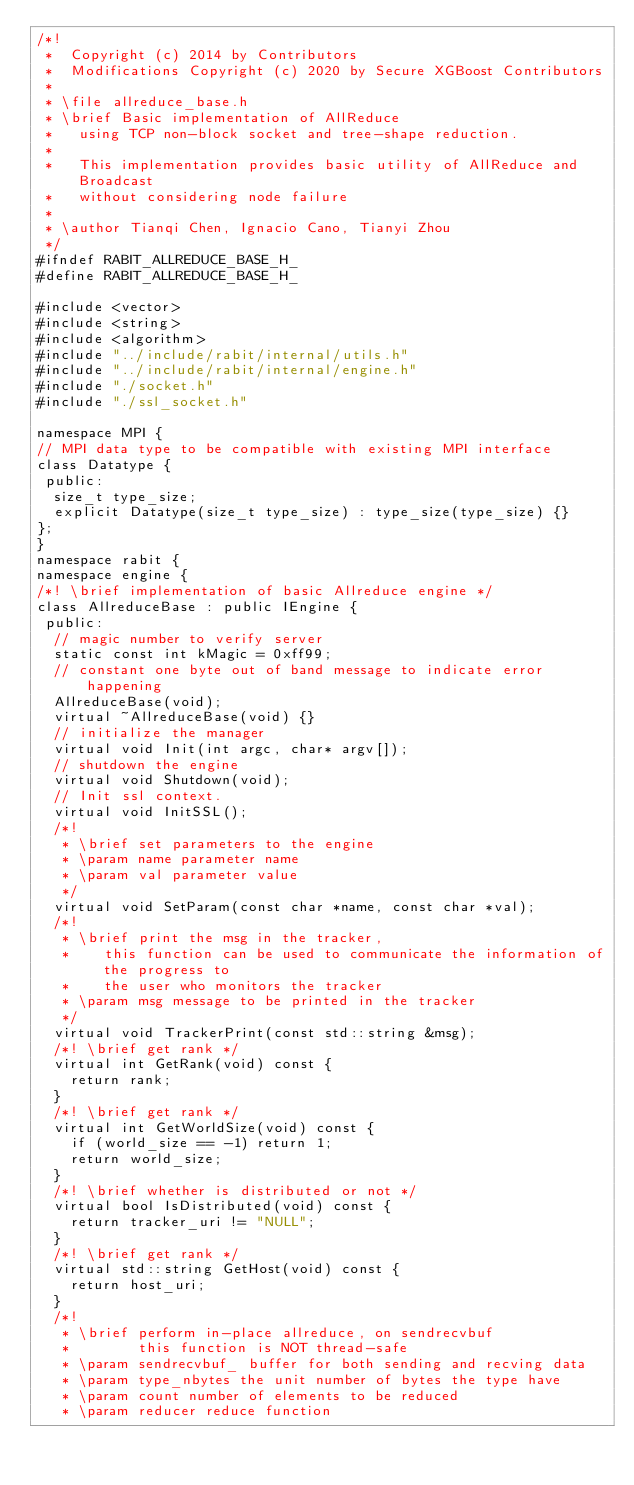Convert code to text. <code><loc_0><loc_0><loc_500><loc_500><_C_>/*!
 *  Copyright (c) 2014 by Contributors
 *  Modifications Copyright (c) 2020 by Secure XGBoost Contributors
 *
 * \file allreduce_base.h
 * \brief Basic implementation of AllReduce
 *   using TCP non-block socket and tree-shape reduction.
 *
 *   This implementation provides basic utility of AllReduce and Broadcast
 *   without considering node failure
 *
 * \author Tianqi Chen, Ignacio Cano, Tianyi Zhou
 */
#ifndef RABIT_ALLREDUCE_BASE_H_
#define RABIT_ALLREDUCE_BASE_H_

#include <vector>
#include <string>
#include <algorithm>
#include "../include/rabit/internal/utils.h"
#include "../include/rabit/internal/engine.h"
#include "./socket.h"
#include "./ssl_socket.h"

namespace MPI {
// MPI data type to be compatible with existing MPI interface
class Datatype {
 public:
  size_t type_size;
  explicit Datatype(size_t type_size) : type_size(type_size) {}
};
}
namespace rabit {
namespace engine {
/*! \brief implementation of basic Allreduce engine */
class AllreduceBase : public IEngine {
 public:
  // magic number to verify server
  static const int kMagic = 0xff99;
  // constant one byte out of band message to indicate error happening
  AllreduceBase(void);
  virtual ~AllreduceBase(void) {}
  // initialize the manager
  virtual void Init(int argc, char* argv[]);
  // shutdown the engine
  virtual void Shutdown(void);
  // Init ssl context.
  virtual void InitSSL();
  /*!
   * \brief set parameters to the engine
   * \param name parameter name
   * \param val parameter value
   */
  virtual void SetParam(const char *name, const char *val);
  /*!
   * \brief print the msg in the tracker,
   *    this function can be used to communicate the information of the progress to
   *    the user who monitors the tracker
   * \param msg message to be printed in the tracker
   */
  virtual void TrackerPrint(const std::string &msg);
  /*! \brief get rank */
  virtual int GetRank(void) const {
    return rank;
  }
  /*! \brief get rank */
  virtual int GetWorldSize(void) const {
    if (world_size == -1) return 1;
    return world_size;
  }
  /*! \brief whether is distributed or not */
  virtual bool IsDistributed(void) const {
    return tracker_uri != "NULL";
  }
  /*! \brief get rank */
  virtual std::string GetHost(void) const {
    return host_uri;
  }
  /*!
   * \brief perform in-place allreduce, on sendrecvbuf
   *        this function is NOT thread-safe
   * \param sendrecvbuf_ buffer for both sending and recving data
   * \param type_nbytes the unit number of bytes the type have
   * \param count number of elements to be reduced
   * \param reducer reduce function</code> 